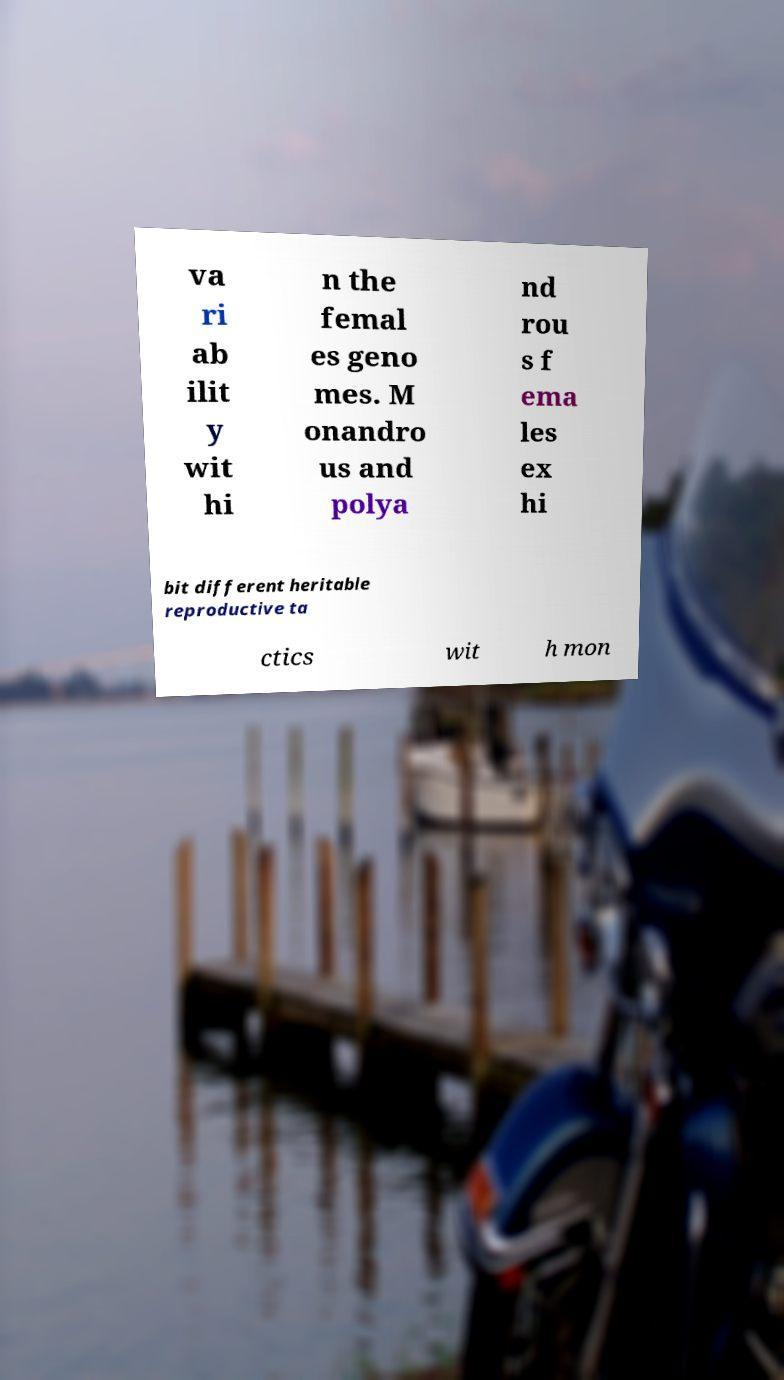Could you assist in decoding the text presented in this image and type it out clearly? va ri ab ilit y wit hi n the femal es geno mes. M onandro us and polya nd rou s f ema les ex hi bit different heritable reproductive ta ctics wit h mon 